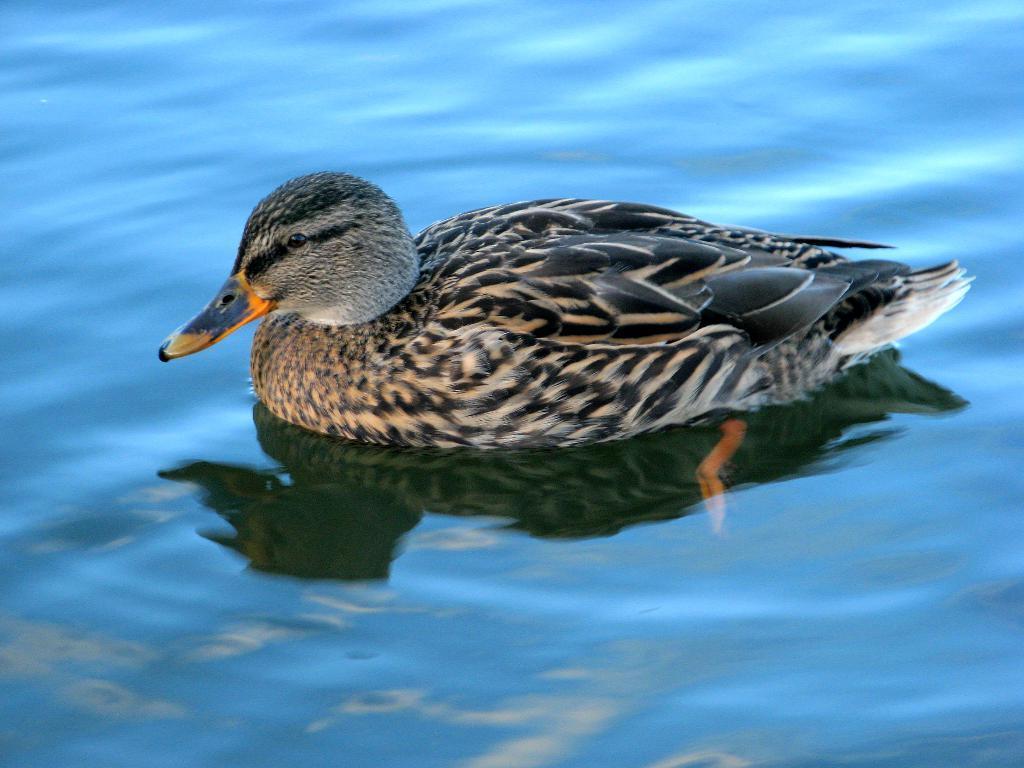How would you summarize this image in a sentence or two? In this image there is water truncated, there is a duck in the water. 